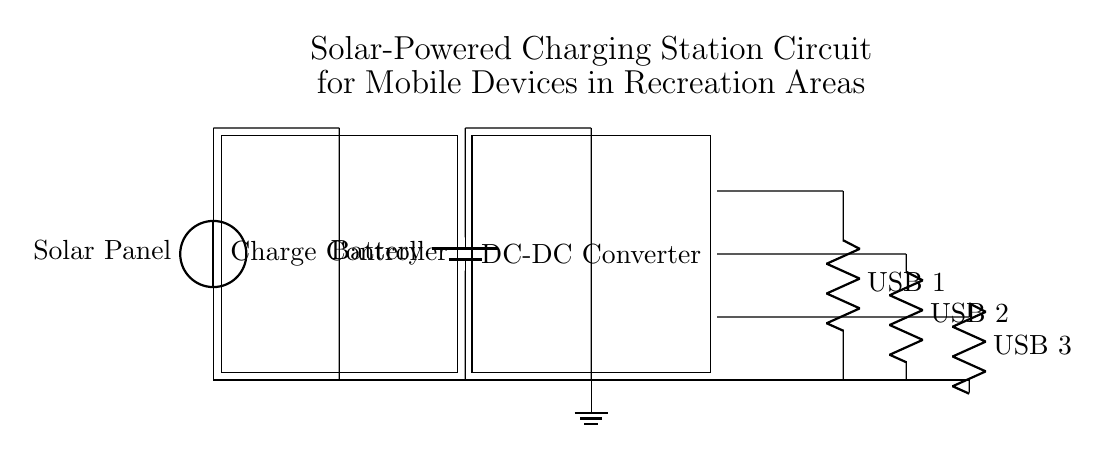What component converts solar energy into electrical energy? The component that converts solar energy into electrical energy is the solar panel, which is indicated at the top of the circuit diagram.
Answer: Solar Panel What is the role of the charge controller? The charge controller regulates the voltage and current coming from the solar panel to the battery to prevent overcharging, improving battery life and safety.
Answer: Regulates charging How many USB outputs are available in this circuit? There are three USB outputs available, as shown by the three resistors labeled USB 1, USB 2, and USB 3.
Answer: Three What is the function of the DC-DC converter in this circuit? The DC-DC converter adjusts the voltage level to ensure that the output voltage for the USB ports is appropriate for charging mobile devices, which typically requires a stable 5V supply.
Answer: Adjusts voltage What voltage does the battery provide? The battery provides a specific voltage which is not explicitly stated on the circuit, but typical batteries used in such applications provide 12 volts.
Answer: Twelve volts Explain why a ground connection is necessary in this circuit? A ground connection is necessary for safety reasons as it provides a reference point for all voltages in the circuit, allowing for proper function and reducing the risk of electric shock.
Answer: Safety reference 